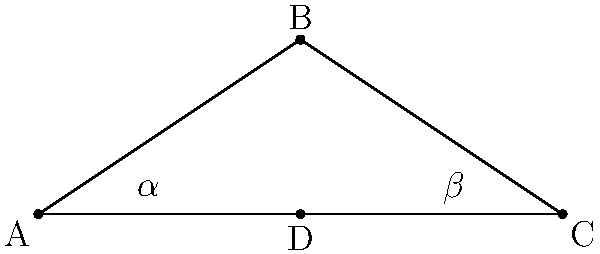In the iconic James Bond bowtie, modeled as two congruent triangles, the base angle $\alpha$ is known to be 30°. If the width of the bowtie (AC) is 6 units, what is the height (BD) of the bowtie? Let's approach this step-by-step:

1) First, we recognize that the bowtie is composed of two congruent right triangles. Triangle ABD is one of these.

2) In triangle ABD, we know that:
   - Angle BAD ($\alpha$) is 30°
   - AD is half of AC, so AD = 3 units

3) In a 30-60-90 triangle, the ratios of the sides are 1 : $\sqrt{3}$ : 2

4) Here, AD (which is 3) corresponds to the longer leg (the hypotenuse is 2 times this length).

5) Therefore, BD (the shorter leg) is $3/\sqrt{3}$ = $\sqrt{3}$ units.

6) We can verify this using trigonometry:
   $\tan 30° = \frac{BD}{AD} = \frac{BD}{3}$

   $BD = 3 \tan 30° = 3 \cdot \frac{1}{\sqrt{3}} = \sqrt{3}$

Thus, the height of the bowtie (BD) is $\sqrt{3}$ units.
Answer: $\sqrt{3}$ units 